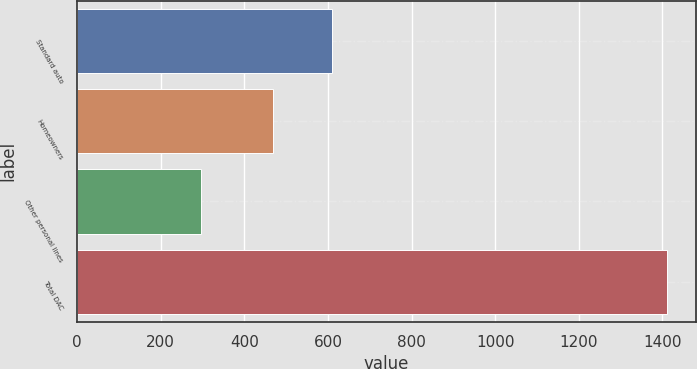Convert chart to OTSL. <chart><loc_0><loc_0><loc_500><loc_500><bar_chart><fcel>Standard auto<fcel>Homeowners<fcel>Other personal lines<fcel>Total DAC<nl><fcel>610<fcel>468<fcel>297<fcel>1410<nl></chart> 